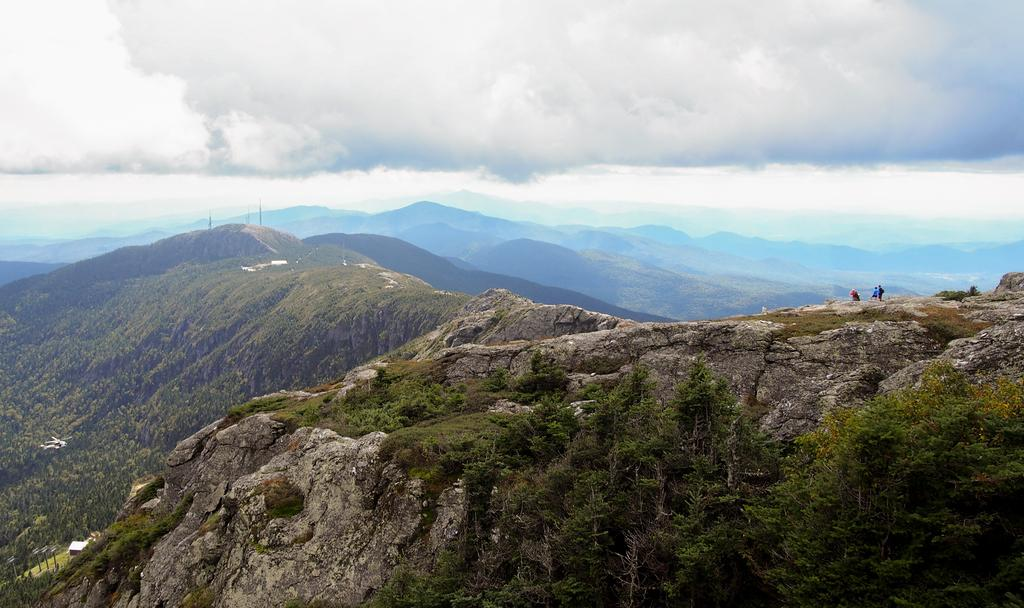Who or what can be seen in the image? There are people in the image. What type of natural landscape is visible in the image? There are hills, trees, and grass in the image. What is visible in the background of the image? The sky is visible in the background of the image, with clouds present. Can you tell me how many buildings are in the image? There are no buildings present in the image; it features people in a natural landscape with hills, trees, and grass. Is the person in the image's father also visible? There is no indication of a father-child relationship in the image, and no specific person is mentioned. The image simply shows people in a natural setting. 